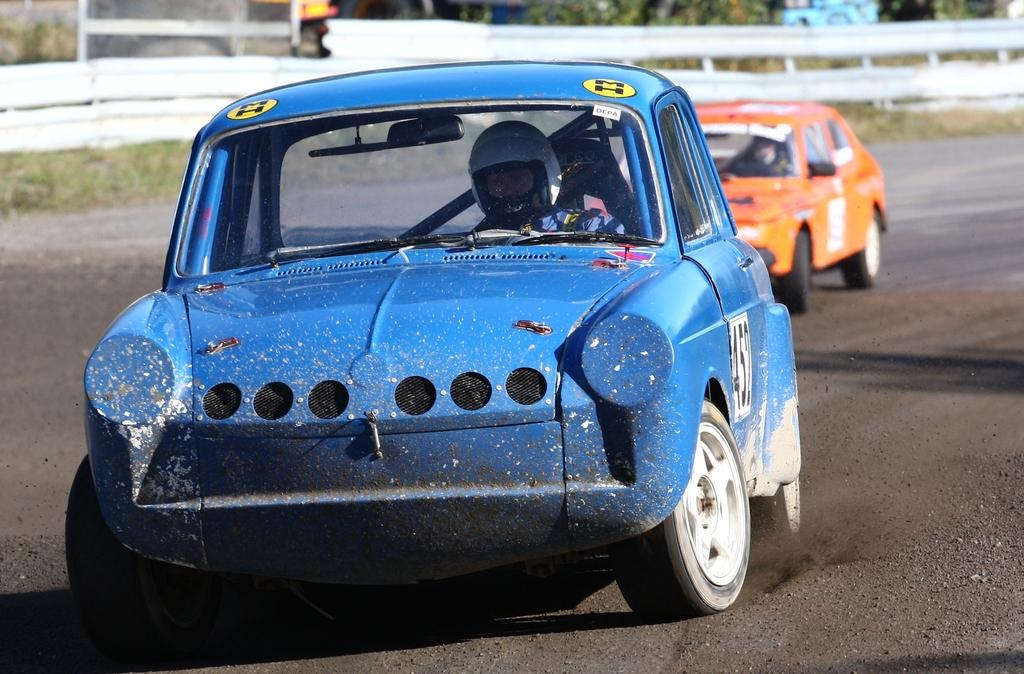What is the main subject of the image? The main subject of the image is cars on a road. Can you describe the background of the image? The background of the image is blurred. What type of bun is being used to control the cars in the image? There is no bun present in the image, and cars are not controlled by buns. 